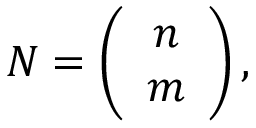Convert formula to latex. <formula><loc_0><loc_0><loc_500><loc_500>N = \left ( \begin{array} { c c } { n } \\ { m } \end{array} \right ) ,</formula> 